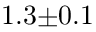Convert formula to latex. <formula><loc_0><loc_0><loc_500><loc_500>1 . 3 { \pm } 0 . 1 \</formula> 